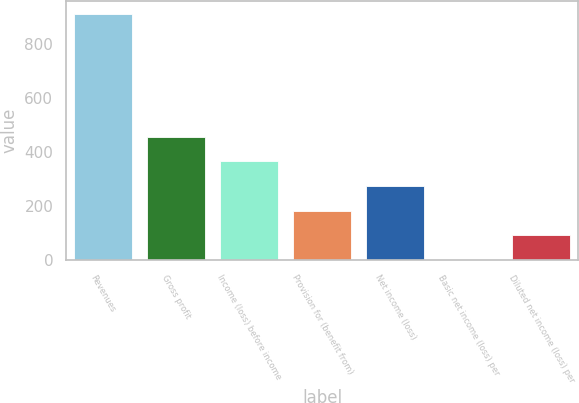Convert chart to OTSL. <chart><loc_0><loc_0><loc_500><loc_500><bar_chart><fcel>Revenues<fcel>Gross profit<fcel>Income (loss) before income<fcel>Provision for (benefit from)<fcel>Net income (loss)<fcel>Basic net income (loss) per<fcel>Diluted net income (loss) per<nl><fcel>913.5<fcel>456.79<fcel>365.44<fcel>182.74<fcel>274.09<fcel>0.04<fcel>91.39<nl></chart> 